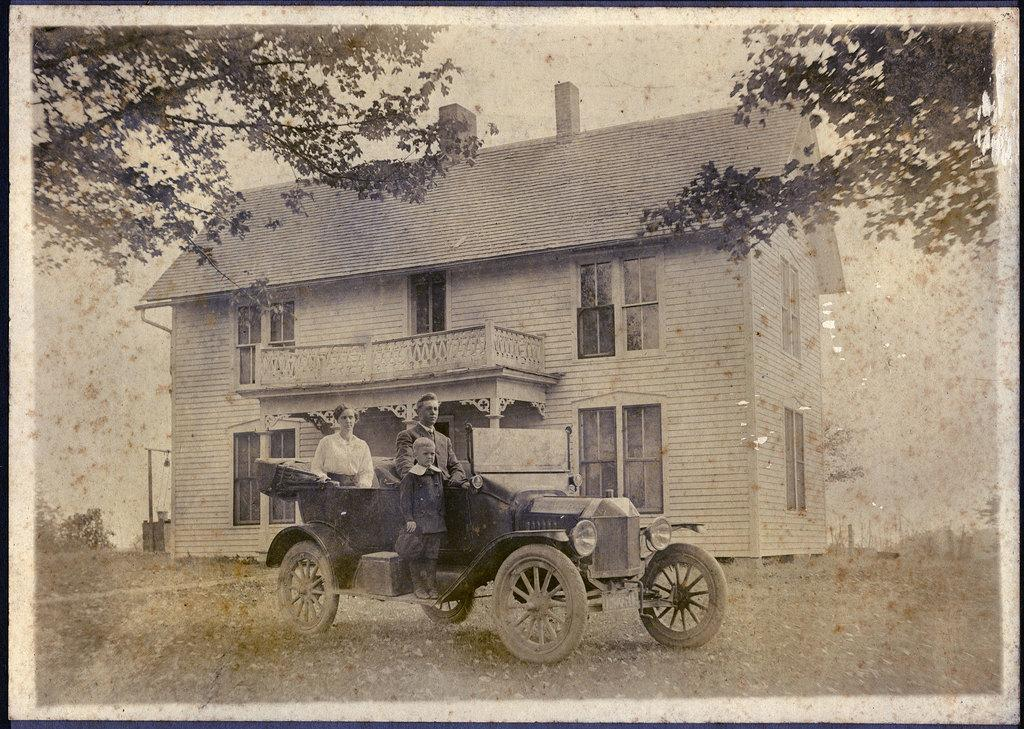How many people are in the car in the image? There are three persons in the car. What type of car is featured in the image? The car is an old vintage car. What can be seen in the background of the image? There are buildings and trees in the background of the image. How many cows are visible in the image? There are no cows present in the image. What caused the vintage car to break down in the image? The image does not show any indication of the car breaking down, nor does it provide any information about the cause. 